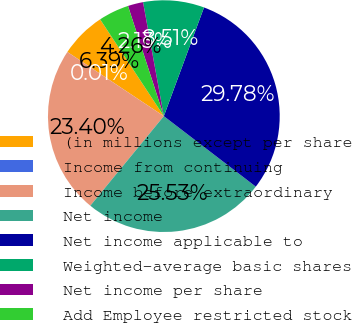Convert chart to OTSL. <chart><loc_0><loc_0><loc_500><loc_500><pie_chart><fcel>(in millions except per share<fcel>Income from continuing<fcel>Income before extraordinary<fcel>Net income<fcel>Net income applicable to<fcel>Weighted-average basic shares<fcel>Net income per share<fcel>Add Employee restricted stock<nl><fcel>6.39%<fcel>0.01%<fcel>23.4%<fcel>25.53%<fcel>29.78%<fcel>8.51%<fcel>2.13%<fcel>4.26%<nl></chart> 